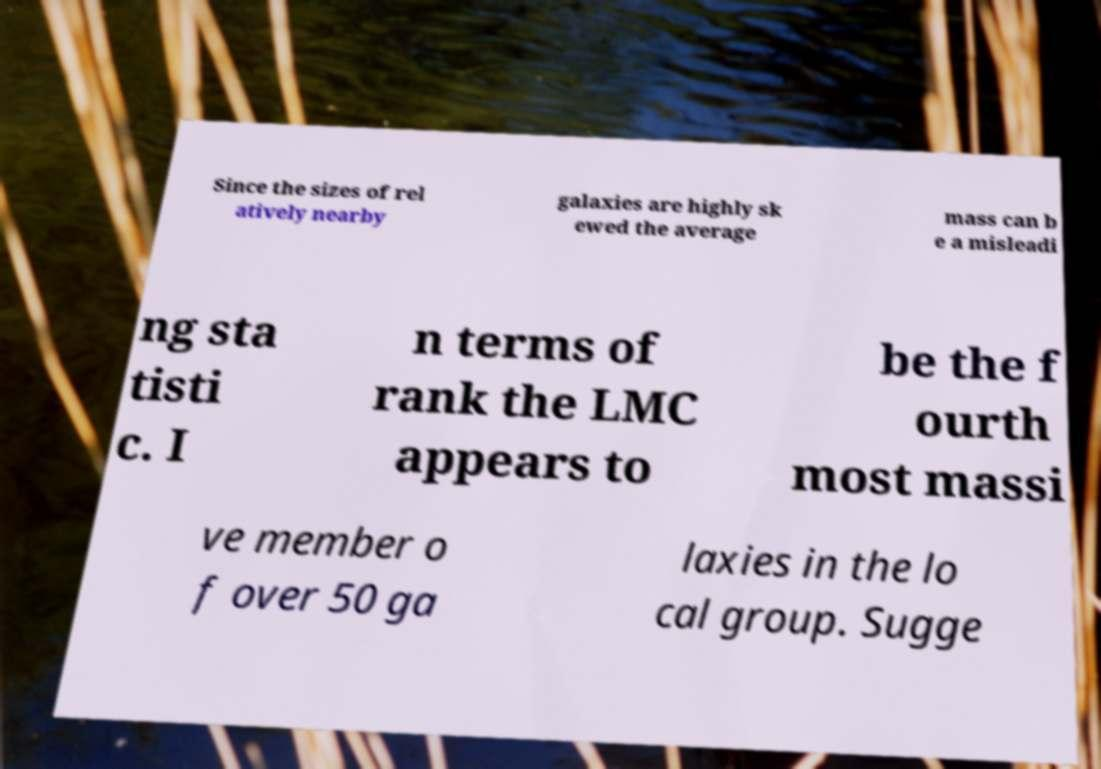Could you extract and type out the text from this image? Since the sizes of rel atively nearby galaxies are highly sk ewed the average mass can b e a misleadi ng sta tisti c. I n terms of rank the LMC appears to be the f ourth most massi ve member o f over 50 ga laxies in the lo cal group. Sugge 